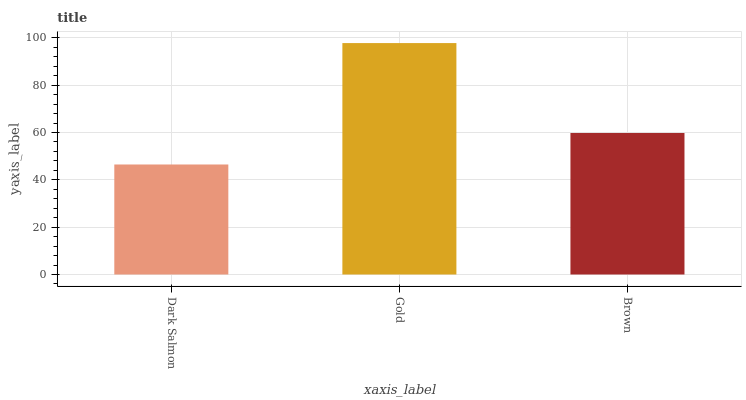Is Dark Salmon the minimum?
Answer yes or no. Yes. Is Gold the maximum?
Answer yes or no. Yes. Is Brown the minimum?
Answer yes or no. No. Is Brown the maximum?
Answer yes or no. No. Is Gold greater than Brown?
Answer yes or no. Yes. Is Brown less than Gold?
Answer yes or no. Yes. Is Brown greater than Gold?
Answer yes or no. No. Is Gold less than Brown?
Answer yes or no. No. Is Brown the high median?
Answer yes or no. Yes. Is Brown the low median?
Answer yes or no. Yes. Is Dark Salmon the high median?
Answer yes or no. No. Is Dark Salmon the low median?
Answer yes or no. No. 